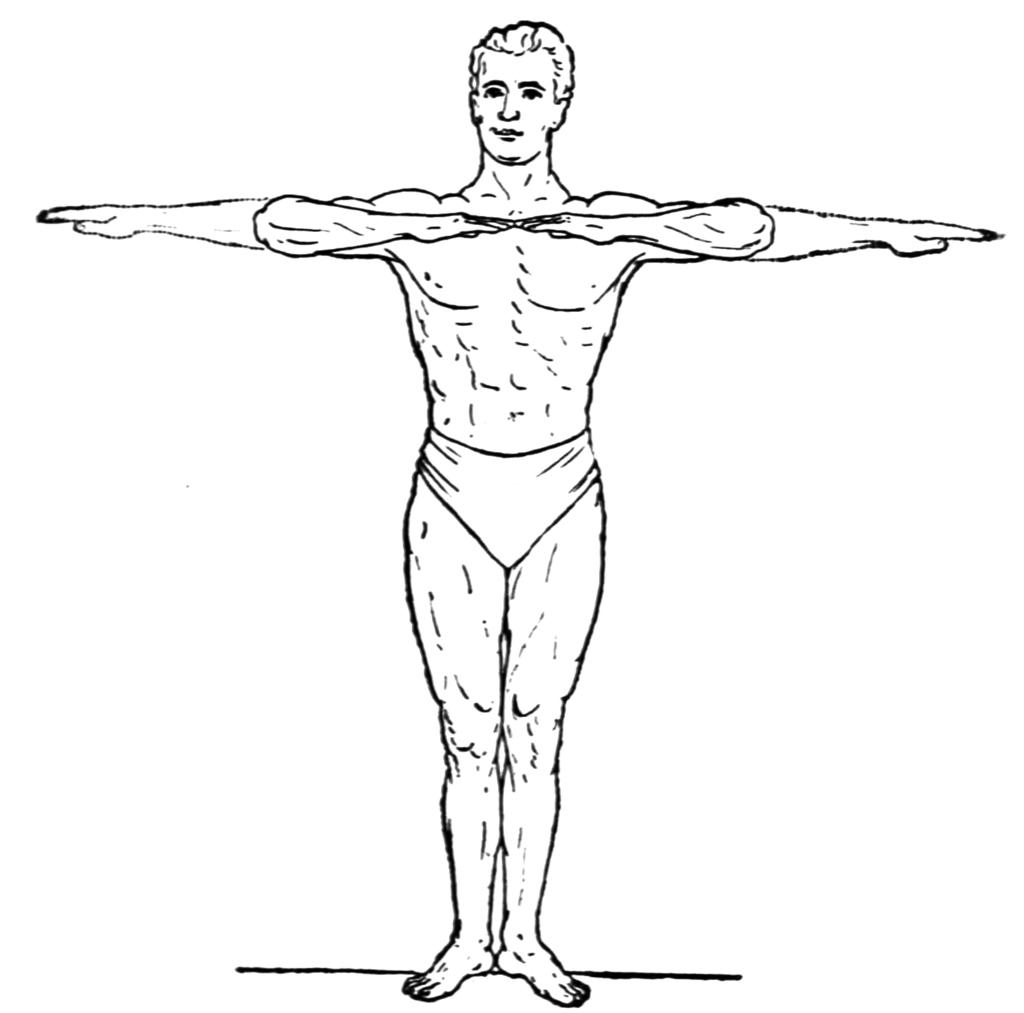What is depicted in the image? The image contains a diagram of a man. What is the man in the diagram doing? The man in the diagram is doing an exercise. What position is the man in the diagram in? The man in the diagram is standing. How many houses can be seen in the background of the image? There are no houses present in the image, as it features a diagram of a man doing an exercise. What type of club is the man holding in the image? There is no club present in the image; it features a diagram of a man doing an exercise. 